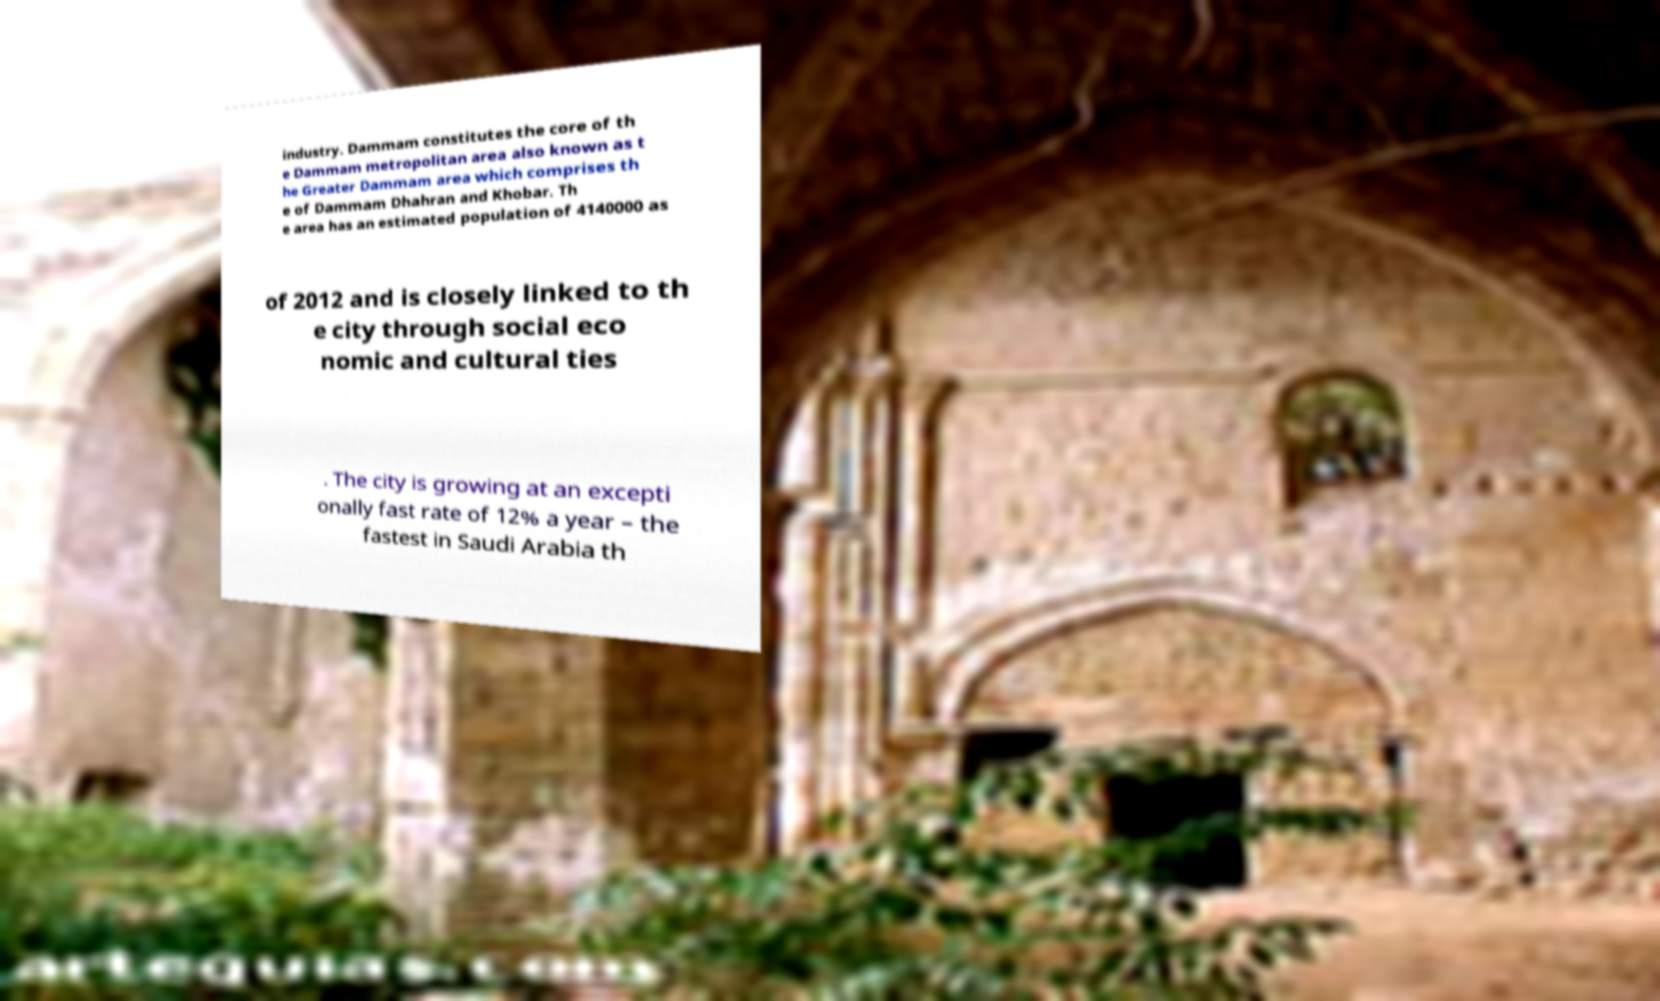Could you extract and type out the text from this image? industry. Dammam constitutes the core of th e Dammam metropolitan area also known as t he Greater Dammam area which comprises th e of Dammam Dhahran and Khobar. Th e area has an estimated population of 4140000 as of 2012 and is closely linked to th e city through social eco nomic and cultural ties . The city is growing at an excepti onally fast rate of 12% a year – the fastest in Saudi Arabia th 